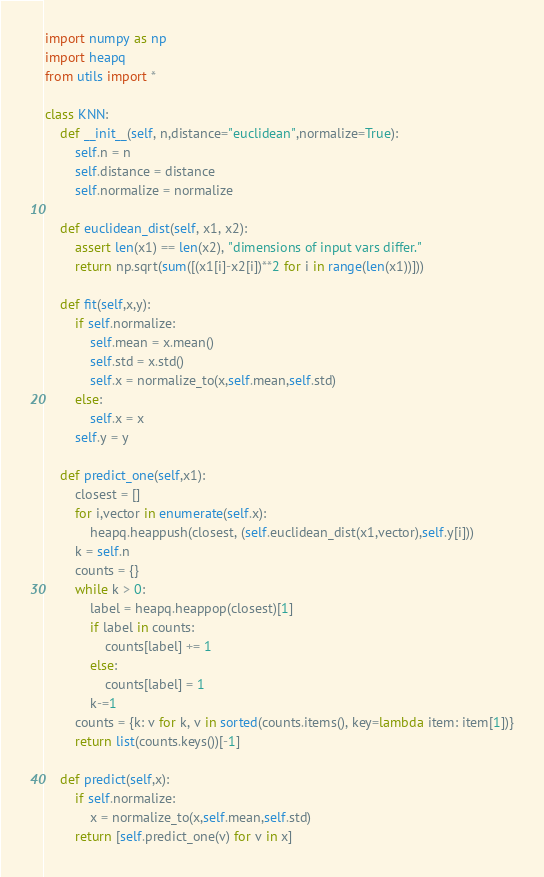<code> <loc_0><loc_0><loc_500><loc_500><_Python_>import numpy as np
import heapq
from utils import *

class KNN:
    def __init__(self, n,distance="euclidean",normalize=True):
        self.n = n
        self.distance = distance
        self.normalize = normalize

    def euclidean_dist(self, x1, x2):
        assert len(x1) == len(x2), "dimensions of input vars differ."
        return np.sqrt(sum([(x1[i]-x2[i])**2 for i in range(len(x1))]))

    def fit(self,x,y):
        if self.normalize:
            self.mean = x.mean()
            self.std = x.std()
            self.x = normalize_to(x,self.mean,self.std)
        else:
            self.x = x
        self.y = y

    def predict_one(self,x1):
        closest = []
        for i,vector in enumerate(self.x):
            heapq.heappush(closest, (self.euclidean_dist(x1,vector),self.y[i]))
        k = self.n
        counts = {}
        while k > 0:
            label = heapq.heappop(closest)[1]
            if label in counts:
                counts[label] += 1
            else:
                counts[label] = 1
            k-=1
        counts = {k: v for k, v in sorted(counts.items(), key=lambda item: item[1])}
        return list(counts.keys())[-1]

    def predict(self,x):
        if self.normalize:
            x = normalize_to(x,self.mean,self.std)
        return [self.predict_one(v) for v in x]
</code> 